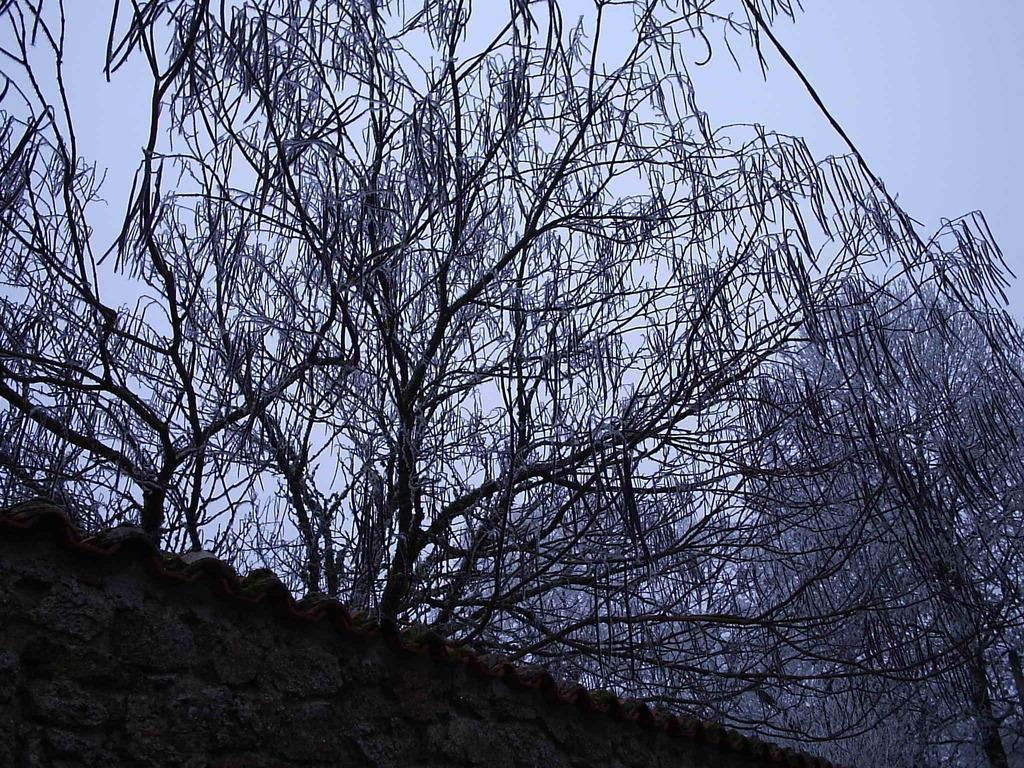What is located directly in front of the viewer in the image? There is a wall in front in the image. What type of vegetation can be seen in the image? There are multiple trees visible in the image. What part of the natural environment is visible in the image? The sky is visible in the background of the image. What type of drug is being used by the turkey in the image? There is no turkey present in the image, and therefore no drug use can be observed. 